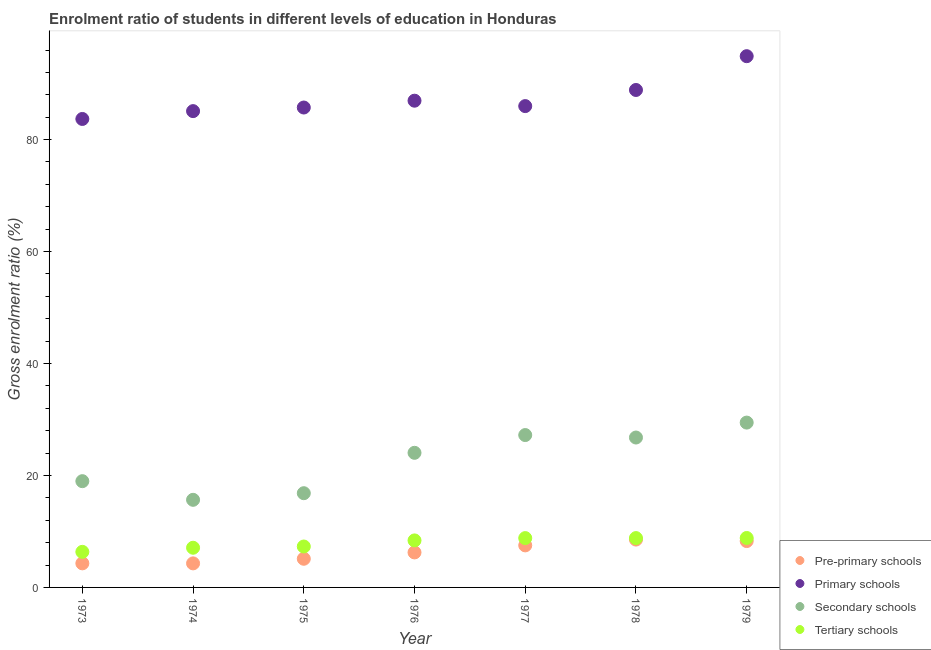What is the gross enrolment ratio in primary schools in 1977?
Ensure brevity in your answer.  85.99. Across all years, what is the maximum gross enrolment ratio in tertiary schools?
Provide a succinct answer. 8.83. Across all years, what is the minimum gross enrolment ratio in primary schools?
Ensure brevity in your answer.  83.69. In which year was the gross enrolment ratio in secondary schools maximum?
Provide a succinct answer. 1979. What is the total gross enrolment ratio in primary schools in the graph?
Provide a succinct answer. 611.21. What is the difference between the gross enrolment ratio in primary schools in 1977 and that in 1979?
Make the answer very short. -8.92. What is the difference between the gross enrolment ratio in pre-primary schools in 1974 and the gross enrolment ratio in tertiary schools in 1973?
Provide a succinct answer. -2.06. What is the average gross enrolment ratio in tertiary schools per year?
Provide a succinct answer. 7.94. In the year 1978, what is the difference between the gross enrolment ratio in secondary schools and gross enrolment ratio in pre-primary schools?
Provide a short and direct response. 18.23. In how many years, is the gross enrolment ratio in tertiary schools greater than 68 %?
Offer a very short reply. 0. What is the ratio of the gross enrolment ratio in tertiary schools in 1973 to that in 1977?
Your answer should be very brief. 0.72. Is the difference between the gross enrolment ratio in tertiary schools in 1974 and 1976 greater than the difference between the gross enrolment ratio in primary schools in 1974 and 1976?
Give a very brief answer. Yes. What is the difference between the highest and the second highest gross enrolment ratio in secondary schools?
Provide a short and direct response. 2.23. What is the difference between the highest and the lowest gross enrolment ratio in secondary schools?
Ensure brevity in your answer.  13.8. Is it the case that in every year, the sum of the gross enrolment ratio in primary schools and gross enrolment ratio in tertiary schools is greater than the sum of gross enrolment ratio in pre-primary schools and gross enrolment ratio in secondary schools?
Your response must be concise. No. Is the gross enrolment ratio in pre-primary schools strictly greater than the gross enrolment ratio in primary schools over the years?
Your answer should be compact. No. Is the gross enrolment ratio in pre-primary schools strictly less than the gross enrolment ratio in tertiary schools over the years?
Give a very brief answer. Yes. How many dotlines are there?
Offer a terse response. 4. How many years are there in the graph?
Make the answer very short. 7. What is the difference between two consecutive major ticks on the Y-axis?
Offer a very short reply. 20. Does the graph contain grids?
Your answer should be very brief. No. Where does the legend appear in the graph?
Keep it short and to the point. Bottom right. How are the legend labels stacked?
Offer a terse response. Vertical. What is the title of the graph?
Ensure brevity in your answer.  Enrolment ratio of students in different levels of education in Honduras. Does "Trade" appear as one of the legend labels in the graph?
Provide a succinct answer. No. What is the label or title of the X-axis?
Offer a very short reply. Year. What is the Gross enrolment ratio (%) of Pre-primary schools in 1973?
Your response must be concise. 4.3. What is the Gross enrolment ratio (%) in Primary schools in 1973?
Your response must be concise. 83.69. What is the Gross enrolment ratio (%) in Secondary schools in 1973?
Make the answer very short. 18.98. What is the Gross enrolment ratio (%) in Tertiary schools in 1973?
Make the answer very short. 6.35. What is the Gross enrolment ratio (%) in Pre-primary schools in 1974?
Provide a short and direct response. 4.3. What is the Gross enrolment ratio (%) of Primary schools in 1974?
Provide a short and direct response. 85.09. What is the Gross enrolment ratio (%) of Secondary schools in 1974?
Your response must be concise. 15.65. What is the Gross enrolment ratio (%) of Tertiary schools in 1974?
Make the answer very short. 7.09. What is the Gross enrolment ratio (%) of Pre-primary schools in 1975?
Your answer should be compact. 5.12. What is the Gross enrolment ratio (%) of Primary schools in 1975?
Provide a succinct answer. 85.73. What is the Gross enrolment ratio (%) of Secondary schools in 1975?
Offer a very short reply. 16.83. What is the Gross enrolment ratio (%) of Tertiary schools in 1975?
Make the answer very short. 7.31. What is the Gross enrolment ratio (%) of Pre-primary schools in 1976?
Your answer should be very brief. 6.25. What is the Gross enrolment ratio (%) of Primary schools in 1976?
Your response must be concise. 86.95. What is the Gross enrolment ratio (%) of Secondary schools in 1976?
Ensure brevity in your answer.  24.05. What is the Gross enrolment ratio (%) of Tertiary schools in 1976?
Make the answer very short. 8.4. What is the Gross enrolment ratio (%) of Pre-primary schools in 1977?
Ensure brevity in your answer.  7.51. What is the Gross enrolment ratio (%) of Primary schools in 1977?
Provide a succinct answer. 85.99. What is the Gross enrolment ratio (%) of Secondary schools in 1977?
Keep it short and to the point. 27.22. What is the Gross enrolment ratio (%) in Tertiary schools in 1977?
Offer a very short reply. 8.81. What is the Gross enrolment ratio (%) in Pre-primary schools in 1978?
Provide a succinct answer. 8.55. What is the Gross enrolment ratio (%) in Primary schools in 1978?
Make the answer very short. 88.86. What is the Gross enrolment ratio (%) of Secondary schools in 1978?
Your response must be concise. 26.78. What is the Gross enrolment ratio (%) in Tertiary schools in 1978?
Your response must be concise. 8.81. What is the Gross enrolment ratio (%) of Pre-primary schools in 1979?
Make the answer very short. 8.28. What is the Gross enrolment ratio (%) in Primary schools in 1979?
Offer a terse response. 94.9. What is the Gross enrolment ratio (%) in Secondary schools in 1979?
Your response must be concise. 29.45. What is the Gross enrolment ratio (%) in Tertiary schools in 1979?
Your response must be concise. 8.83. Across all years, what is the maximum Gross enrolment ratio (%) of Pre-primary schools?
Your answer should be compact. 8.55. Across all years, what is the maximum Gross enrolment ratio (%) in Primary schools?
Keep it short and to the point. 94.9. Across all years, what is the maximum Gross enrolment ratio (%) in Secondary schools?
Your response must be concise. 29.45. Across all years, what is the maximum Gross enrolment ratio (%) in Tertiary schools?
Keep it short and to the point. 8.83. Across all years, what is the minimum Gross enrolment ratio (%) in Pre-primary schools?
Your response must be concise. 4.3. Across all years, what is the minimum Gross enrolment ratio (%) in Primary schools?
Ensure brevity in your answer.  83.69. Across all years, what is the minimum Gross enrolment ratio (%) of Secondary schools?
Provide a succinct answer. 15.65. Across all years, what is the minimum Gross enrolment ratio (%) in Tertiary schools?
Provide a short and direct response. 6.35. What is the total Gross enrolment ratio (%) in Pre-primary schools in the graph?
Give a very brief answer. 44.31. What is the total Gross enrolment ratio (%) in Primary schools in the graph?
Give a very brief answer. 611.21. What is the total Gross enrolment ratio (%) of Secondary schools in the graph?
Provide a succinct answer. 158.95. What is the total Gross enrolment ratio (%) of Tertiary schools in the graph?
Your answer should be very brief. 55.61. What is the difference between the Gross enrolment ratio (%) of Pre-primary schools in 1973 and that in 1974?
Your answer should be very brief. 0. What is the difference between the Gross enrolment ratio (%) of Primary schools in 1973 and that in 1974?
Keep it short and to the point. -1.4. What is the difference between the Gross enrolment ratio (%) of Secondary schools in 1973 and that in 1974?
Provide a short and direct response. 3.33. What is the difference between the Gross enrolment ratio (%) in Tertiary schools in 1973 and that in 1974?
Keep it short and to the point. -0.73. What is the difference between the Gross enrolment ratio (%) in Pre-primary schools in 1973 and that in 1975?
Your answer should be very brief. -0.82. What is the difference between the Gross enrolment ratio (%) in Primary schools in 1973 and that in 1975?
Offer a terse response. -2.04. What is the difference between the Gross enrolment ratio (%) in Secondary schools in 1973 and that in 1975?
Make the answer very short. 2.15. What is the difference between the Gross enrolment ratio (%) of Tertiary schools in 1973 and that in 1975?
Keep it short and to the point. -0.96. What is the difference between the Gross enrolment ratio (%) in Pre-primary schools in 1973 and that in 1976?
Offer a very short reply. -1.95. What is the difference between the Gross enrolment ratio (%) in Primary schools in 1973 and that in 1976?
Your answer should be very brief. -3.26. What is the difference between the Gross enrolment ratio (%) in Secondary schools in 1973 and that in 1976?
Your answer should be compact. -5.06. What is the difference between the Gross enrolment ratio (%) of Tertiary schools in 1973 and that in 1976?
Provide a short and direct response. -2.04. What is the difference between the Gross enrolment ratio (%) in Pre-primary schools in 1973 and that in 1977?
Provide a short and direct response. -3.21. What is the difference between the Gross enrolment ratio (%) in Primary schools in 1973 and that in 1977?
Make the answer very short. -2.3. What is the difference between the Gross enrolment ratio (%) of Secondary schools in 1973 and that in 1977?
Offer a terse response. -8.24. What is the difference between the Gross enrolment ratio (%) of Tertiary schools in 1973 and that in 1977?
Make the answer very short. -2.46. What is the difference between the Gross enrolment ratio (%) of Pre-primary schools in 1973 and that in 1978?
Keep it short and to the point. -4.25. What is the difference between the Gross enrolment ratio (%) in Primary schools in 1973 and that in 1978?
Your answer should be compact. -5.18. What is the difference between the Gross enrolment ratio (%) in Secondary schools in 1973 and that in 1978?
Keep it short and to the point. -7.8. What is the difference between the Gross enrolment ratio (%) of Tertiary schools in 1973 and that in 1978?
Offer a very short reply. -2.46. What is the difference between the Gross enrolment ratio (%) of Pre-primary schools in 1973 and that in 1979?
Make the answer very short. -3.98. What is the difference between the Gross enrolment ratio (%) of Primary schools in 1973 and that in 1979?
Offer a terse response. -11.21. What is the difference between the Gross enrolment ratio (%) in Secondary schools in 1973 and that in 1979?
Give a very brief answer. -10.46. What is the difference between the Gross enrolment ratio (%) of Tertiary schools in 1973 and that in 1979?
Offer a very short reply. -2.48. What is the difference between the Gross enrolment ratio (%) in Pre-primary schools in 1974 and that in 1975?
Offer a terse response. -0.82. What is the difference between the Gross enrolment ratio (%) of Primary schools in 1974 and that in 1975?
Make the answer very short. -0.64. What is the difference between the Gross enrolment ratio (%) of Secondary schools in 1974 and that in 1975?
Your answer should be very brief. -1.18. What is the difference between the Gross enrolment ratio (%) in Tertiary schools in 1974 and that in 1975?
Ensure brevity in your answer.  -0.22. What is the difference between the Gross enrolment ratio (%) in Pre-primary schools in 1974 and that in 1976?
Offer a very short reply. -1.96. What is the difference between the Gross enrolment ratio (%) of Primary schools in 1974 and that in 1976?
Provide a short and direct response. -1.86. What is the difference between the Gross enrolment ratio (%) of Secondary schools in 1974 and that in 1976?
Your response must be concise. -8.4. What is the difference between the Gross enrolment ratio (%) in Tertiary schools in 1974 and that in 1976?
Your answer should be compact. -1.31. What is the difference between the Gross enrolment ratio (%) in Pre-primary schools in 1974 and that in 1977?
Make the answer very short. -3.21. What is the difference between the Gross enrolment ratio (%) in Primary schools in 1974 and that in 1977?
Keep it short and to the point. -0.9. What is the difference between the Gross enrolment ratio (%) of Secondary schools in 1974 and that in 1977?
Your answer should be compact. -11.57. What is the difference between the Gross enrolment ratio (%) in Tertiary schools in 1974 and that in 1977?
Your answer should be very brief. -1.72. What is the difference between the Gross enrolment ratio (%) in Pre-primary schools in 1974 and that in 1978?
Your answer should be compact. -4.25. What is the difference between the Gross enrolment ratio (%) of Primary schools in 1974 and that in 1978?
Your response must be concise. -3.78. What is the difference between the Gross enrolment ratio (%) of Secondary schools in 1974 and that in 1978?
Your response must be concise. -11.13. What is the difference between the Gross enrolment ratio (%) in Tertiary schools in 1974 and that in 1978?
Give a very brief answer. -1.73. What is the difference between the Gross enrolment ratio (%) of Pre-primary schools in 1974 and that in 1979?
Make the answer very short. -3.98. What is the difference between the Gross enrolment ratio (%) of Primary schools in 1974 and that in 1979?
Offer a terse response. -9.81. What is the difference between the Gross enrolment ratio (%) in Secondary schools in 1974 and that in 1979?
Offer a very short reply. -13.8. What is the difference between the Gross enrolment ratio (%) of Tertiary schools in 1974 and that in 1979?
Your response must be concise. -1.74. What is the difference between the Gross enrolment ratio (%) of Pre-primary schools in 1975 and that in 1976?
Your answer should be compact. -1.13. What is the difference between the Gross enrolment ratio (%) in Primary schools in 1975 and that in 1976?
Provide a succinct answer. -1.22. What is the difference between the Gross enrolment ratio (%) in Secondary schools in 1975 and that in 1976?
Your answer should be compact. -7.21. What is the difference between the Gross enrolment ratio (%) of Tertiary schools in 1975 and that in 1976?
Your answer should be very brief. -1.09. What is the difference between the Gross enrolment ratio (%) of Pre-primary schools in 1975 and that in 1977?
Your answer should be very brief. -2.39. What is the difference between the Gross enrolment ratio (%) of Primary schools in 1975 and that in 1977?
Your response must be concise. -0.26. What is the difference between the Gross enrolment ratio (%) in Secondary schools in 1975 and that in 1977?
Make the answer very short. -10.39. What is the difference between the Gross enrolment ratio (%) of Tertiary schools in 1975 and that in 1977?
Your response must be concise. -1.5. What is the difference between the Gross enrolment ratio (%) of Pre-primary schools in 1975 and that in 1978?
Your answer should be very brief. -3.43. What is the difference between the Gross enrolment ratio (%) of Primary schools in 1975 and that in 1978?
Make the answer very short. -3.13. What is the difference between the Gross enrolment ratio (%) in Secondary schools in 1975 and that in 1978?
Ensure brevity in your answer.  -9.95. What is the difference between the Gross enrolment ratio (%) in Tertiary schools in 1975 and that in 1978?
Ensure brevity in your answer.  -1.5. What is the difference between the Gross enrolment ratio (%) of Pre-primary schools in 1975 and that in 1979?
Your answer should be very brief. -3.16. What is the difference between the Gross enrolment ratio (%) in Primary schools in 1975 and that in 1979?
Offer a very short reply. -9.17. What is the difference between the Gross enrolment ratio (%) in Secondary schools in 1975 and that in 1979?
Make the answer very short. -12.61. What is the difference between the Gross enrolment ratio (%) of Tertiary schools in 1975 and that in 1979?
Provide a succinct answer. -1.52. What is the difference between the Gross enrolment ratio (%) in Pre-primary schools in 1976 and that in 1977?
Give a very brief answer. -1.26. What is the difference between the Gross enrolment ratio (%) of Primary schools in 1976 and that in 1977?
Offer a very short reply. 0.97. What is the difference between the Gross enrolment ratio (%) of Secondary schools in 1976 and that in 1977?
Offer a terse response. -3.17. What is the difference between the Gross enrolment ratio (%) in Tertiary schools in 1976 and that in 1977?
Your response must be concise. -0.41. What is the difference between the Gross enrolment ratio (%) of Pre-primary schools in 1976 and that in 1978?
Your answer should be compact. -2.3. What is the difference between the Gross enrolment ratio (%) in Primary schools in 1976 and that in 1978?
Ensure brevity in your answer.  -1.91. What is the difference between the Gross enrolment ratio (%) of Secondary schools in 1976 and that in 1978?
Offer a terse response. -2.73. What is the difference between the Gross enrolment ratio (%) in Tertiary schools in 1976 and that in 1978?
Offer a terse response. -0.42. What is the difference between the Gross enrolment ratio (%) in Pre-primary schools in 1976 and that in 1979?
Provide a succinct answer. -2.03. What is the difference between the Gross enrolment ratio (%) of Primary schools in 1976 and that in 1979?
Provide a short and direct response. -7.95. What is the difference between the Gross enrolment ratio (%) in Secondary schools in 1976 and that in 1979?
Provide a succinct answer. -5.4. What is the difference between the Gross enrolment ratio (%) in Tertiary schools in 1976 and that in 1979?
Your response must be concise. -0.43. What is the difference between the Gross enrolment ratio (%) in Pre-primary schools in 1977 and that in 1978?
Ensure brevity in your answer.  -1.04. What is the difference between the Gross enrolment ratio (%) in Primary schools in 1977 and that in 1978?
Offer a very short reply. -2.88. What is the difference between the Gross enrolment ratio (%) in Secondary schools in 1977 and that in 1978?
Give a very brief answer. 0.44. What is the difference between the Gross enrolment ratio (%) in Tertiary schools in 1977 and that in 1978?
Offer a terse response. -0. What is the difference between the Gross enrolment ratio (%) of Pre-primary schools in 1977 and that in 1979?
Ensure brevity in your answer.  -0.77. What is the difference between the Gross enrolment ratio (%) in Primary schools in 1977 and that in 1979?
Give a very brief answer. -8.92. What is the difference between the Gross enrolment ratio (%) of Secondary schools in 1977 and that in 1979?
Give a very brief answer. -2.23. What is the difference between the Gross enrolment ratio (%) in Tertiary schools in 1977 and that in 1979?
Give a very brief answer. -0.02. What is the difference between the Gross enrolment ratio (%) in Pre-primary schools in 1978 and that in 1979?
Offer a terse response. 0.27. What is the difference between the Gross enrolment ratio (%) in Primary schools in 1978 and that in 1979?
Your answer should be very brief. -6.04. What is the difference between the Gross enrolment ratio (%) in Secondary schools in 1978 and that in 1979?
Give a very brief answer. -2.67. What is the difference between the Gross enrolment ratio (%) in Tertiary schools in 1978 and that in 1979?
Your answer should be compact. -0.02. What is the difference between the Gross enrolment ratio (%) of Pre-primary schools in 1973 and the Gross enrolment ratio (%) of Primary schools in 1974?
Your answer should be very brief. -80.79. What is the difference between the Gross enrolment ratio (%) in Pre-primary schools in 1973 and the Gross enrolment ratio (%) in Secondary schools in 1974?
Provide a short and direct response. -11.35. What is the difference between the Gross enrolment ratio (%) of Pre-primary schools in 1973 and the Gross enrolment ratio (%) of Tertiary schools in 1974?
Offer a terse response. -2.79. What is the difference between the Gross enrolment ratio (%) in Primary schools in 1973 and the Gross enrolment ratio (%) in Secondary schools in 1974?
Your answer should be compact. 68.04. What is the difference between the Gross enrolment ratio (%) of Primary schools in 1973 and the Gross enrolment ratio (%) of Tertiary schools in 1974?
Your answer should be compact. 76.6. What is the difference between the Gross enrolment ratio (%) in Secondary schools in 1973 and the Gross enrolment ratio (%) in Tertiary schools in 1974?
Make the answer very short. 11.89. What is the difference between the Gross enrolment ratio (%) of Pre-primary schools in 1973 and the Gross enrolment ratio (%) of Primary schools in 1975?
Provide a short and direct response. -81.43. What is the difference between the Gross enrolment ratio (%) in Pre-primary schools in 1973 and the Gross enrolment ratio (%) in Secondary schools in 1975?
Keep it short and to the point. -12.53. What is the difference between the Gross enrolment ratio (%) in Pre-primary schools in 1973 and the Gross enrolment ratio (%) in Tertiary schools in 1975?
Give a very brief answer. -3.01. What is the difference between the Gross enrolment ratio (%) in Primary schools in 1973 and the Gross enrolment ratio (%) in Secondary schools in 1975?
Give a very brief answer. 66.85. What is the difference between the Gross enrolment ratio (%) of Primary schools in 1973 and the Gross enrolment ratio (%) of Tertiary schools in 1975?
Offer a terse response. 76.38. What is the difference between the Gross enrolment ratio (%) of Secondary schools in 1973 and the Gross enrolment ratio (%) of Tertiary schools in 1975?
Ensure brevity in your answer.  11.67. What is the difference between the Gross enrolment ratio (%) in Pre-primary schools in 1973 and the Gross enrolment ratio (%) in Primary schools in 1976?
Ensure brevity in your answer.  -82.65. What is the difference between the Gross enrolment ratio (%) of Pre-primary schools in 1973 and the Gross enrolment ratio (%) of Secondary schools in 1976?
Provide a short and direct response. -19.75. What is the difference between the Gross enrolment ratio (%) in Pre-primary schools in 1973 and the Gross enrolment ratio (%) in Tertiary schools in 1976?
Provide a succinct answer. -4.1. What is the difference between the Gross enrolment ratio (%) of Primary schools in 1973 and the Gross enrolment ratio (%) of Secondary schools in 1976?
Provide a short and direct response. 59.64. What is the difference between the Gross enrolment ratio (%) of Primary schools in 1973 and the Gross enrolment ratio (%) of Tertiary schools in 1976?
Keep it short and to the point. 75.29. What is the difference between the Gross enrolment ratio (%) of Secondary schools in 1973 and the Gross enrolment ratio (%) of Tertiary schools in 1976?
Offer a terse response. 10.58. What is the difference between the Gross enrolment ratio (%) in Pre-primary schools in 1973 and the Gross enrolment ratio (%) in Primary schools in 1977?
Ensure brevity in your answer.  -81.68. What is the difference between the Gross enrolment ratio (%) in Pre-primary schools in 1973 and the Gross enrolment ratio (%) in Secondary schools in 1977?
Your response must be concise. -22.92. What is the difference between the Gross enrolment ratio (%) of Pre-primary schools in 1973 and the Gross enrolment ratio (%) of Tertiary schools in 1977?
Make the answer very short. -4.51. What is the difference between the Gross enrolment ratio (%) in Primary schools in 1973 and the Gross enrolment ratio (%) in Secondary schools in 1977?
Provide a succinct answer. 56.47. What is the difference between the Gross enrolment ratio (%) of Primary schools in 1973 and the Gross enrolment ratio (%) of Tertiary schools in 1977?
Your answer should be very brief. 74.87. What is the difference between the Gross enrolment ratio (%) of Secondary schools in 1973 and the Gross enrolment ratio (%) of Tertiary schools in 1977?
Ensure brevity in your answer.  10.17. What is the difference between the Gross enrolment ratio (%) of Pre-primary schools in 1973 and the Gross enrolment ratio (%) of Primary schools in 1978?
Your answer should be very brief. -84.56. What is the difference between the Gross enrolment ratio (%) in Pre-primary schools in 1973 and the Gross enrolment ratio (%) in Secondary schools in 1978?
Give a very brief answer. -22.48. What is the difference between the Gross enrolment ratio (%) in Pre-primary schools in 1973 and the Gross enrolment ratio (%) in Tertiary schools in 1978?
Your answer should be compact. -4.51. What is the difference between the Gross enrolment ratio (%) in Primary schools in 1973 and the Gross enrolment ratio (%) in Secondary schools in 1978?
Offer a very short reply. 56.91. What is the difference between the Gross enrolment ratio (%) in Primary schools in 1973 and the Gross enrolment ratio (%) in Tertiary schools in 1978?
Your answer should be very brief. 74.87. What is the difference between the Gross enrolment ratio (%) of Secondary schools in 1973 and the Gross enrolment ratio (%) of Tertiary schools in 1978?
Your answer should be compact. 10.17. What is the difference between the Gross enrolment ratio (%) in Pre-primary schools in 1973 and the Gross enrolment ratio (%) in Primary schools in 1979?
Ensure brevity in your answer.  -90.6. What is the difference between the Gross enrolment ratio (%) in Pre-primary schools in 1973 and the Gross enrolment ratio (%) in Secondary schools in 1979?
Give a very brief answer. -25.15. What is the difference between the Gross enrolment ratio (%) in Pre-primary schools in 1973 and the Gross enrolment ratio (%) in Tertiary schools in 1979?
Your response must be concise. -4.53. What is the difference between the Gross enrolment ratio (%) of Primary schools in 1973 and the Gross enrolment ratio (%) of Secondary schools in 1979?
Keep it short and to the point. 54.24. What is the difference between the Gross enrolment ratio (%) in Primary schools in 1973 and the Gross enrolment ratio (%) in Tertiary schools in 1979?
Your answer should be very brief. 74.86. What is the difference between the Gross enrolment ratio (%) in Secondary schools in 1973 and the Gross enrolment ratio (%) in Tertiary schools in 1979?
Keep it short and to the point. 10.15. What is the difference between the Gross enrolment ratio (%) in Pre-primary schools in 1974 and the Gross enrolment ratio (%) in Primary schools in 1975?
Provide a short and direct response. -81.43. What is the difference between the Gross enrolment ratio (%) in Pre-primary schools in 1974 and the Gross enrolment ratio (%) in Secondary schools in 1975?
Ensure brevity in your answer.  -12.54. What is the difference between the Gross enrolment ratio (%) in Pre-primary schools in 1974 and the Gross enrolment ratio (%) in Tertiary schools in 1975?
Your answer should be very brief. -3.01. What is the difference between the Gross enrolment ratio (%) in Primary schools in 1974 and the Gross enrolment ratio (%) in Secondary schools in 1975?
Provide a short and direct response. 68.25. What is the difference between the Gross enrolment ratio (%) of Primary schools in 1974 and the Gross enrolment ratio (%) of Tertiary schools in 1975?
Keep it short and to the point. 77.78. What is the difference between the Gross enrolment ratio (%) in Secondary schools in 1974 and the Gross enrolment ratio (%) in Tertiary schools in 1975?
Your response must be concise. 8.34. What is the difference between the Gross enrolment ratio (%) in Pre-primary schools in 1974 and the Gross enrolment ratio (%) in Primary schools in 1976?
Make the answer very short. -82.65. What is the difference between the Gross enrolment ratio (%) in Pre-primary schools in 1974 and the Gross enrolment ratio (%) in Secondary schools in 1976?
Provide a short and direct response. -19.75. What is the difference between the Gross enrolment ratio (%) of Pre-primary schools in 1974 and the Gross enrolment ratio (%) of Tertiary schools in 1976?
Your answer should be very brief. -4.1. What is the difference between the Gross enrolment ratio (%) of Primary schools in 1974 and the Gross enrolment ratio (%) of Secondary schools in 1976?
Offer a very short reply. 61.04. What is the difference between the Gross enrolment ratio (%) of Primary schools in 1974 and the Gross enrolment ratio (%) of Tertiary schools in 1976?
Offer a very short reply. 76.69. What is the difference between the Gross enrolment ratio (%) in Secondary schools in 1974 and the Gross enrolment ratio (%) in Tertiary schools in 1976?
Keep it short and to the point. 7.25. What is the difference between the Gross enrolment ratio (%) in Pre-primary schools in 1974 and the Gross enrolment ratio (%) in Primary schools in 1977?
Provide a short and direct response. -81.69. What is the difference between the Gross enrolment ratio (%) in Pre-primary schools in 1974 and the Gross enrolment ratio (%) in Secondary schools in 1977?
Offer a very short reply. -22.92. What is the difference between the Gross enrolment ratio (%) in Pre-primary schools in 1974 and the Gross enrolment ratio (%) in Tertiary schools in 1977?
Your response must be concise. -4.52. What is the difference between the Gross enrolment ratio (%) in Primary schools in 1974 and the Gross enrolment ratio (%) in Secondary schools in 1977?
Your response must be concise. 57.87. What is the difference between the Gross enrolment ratio (%) of Primary schools in 1974 and the Gross enrolment ratio (%) of Tertiary schools in 1977?
Your response must be concise. 76.27. What is the difference between the Gross enrolment ratio (%) of Secondary schools in 1974 and the Gross enrolment ratio (%) of Tertiary schools in 1977?
Offer a terse response. 6.84. What is the difference between the Gross enrolment ratio (%) in Pre-primary schools in 1974 and the Gross enrolment ratio (%) in Primary schools in 1978?
Ensure brevity in your answer.  -84.57. What is the difference between the Gross enrolment ratio (%) in Pre-primary schools in 1974 and the Gross enrolment ratio (%) in Secondary schools in 1978?
Make the answer very short. -22.48. What is the difference between the Gross enrolment ratio (%) of Pre-primary schools in 1974 and the Gross enrolment ratio (%) of Tertiary schools in 1978?
Keep it short and to the point. -4.52. What is the difference between the Gross enrolment ratio (%) of Primary schools in 1974 and the Gross enrolment ratio (%) of Secondary schools in 1978?
Provide a succinct answer. 58.31. What is the difference between the Gross enrolment ratio (%) in Primary schools in 1974 and the Gross enrolment ratio (%) in Tertiary schools in 1978?
Offer a very short reply. 76.27. What is the difference between the Gross enrolment ratio (%) of Secondary schools in 1974 and the Gross enrolment ratio (%) of Tertiary schools in 1978?
Provide a succinct answer. 6.84. What is the difference between the Gross enrolment ratio (%) of Pre-primary schools in 1974 and the Gross enrolment ratio (%) of Primary schools in 1979?
Ensure brevity in your answer.  -90.61. What is the difference between the Gross enrolment ratio (%) of Pre-primary schools in 1974 and the Gross enrolment ratio (%) of Secondary schools in 1979?
Offer a very short reply. -25.15. What is the difference between the Gross enrolment ratio (%) of Pre-primary schools in 1974 and the Gross enrolment ratio (%) of Tertiary schools in 1979?
Offer a very short reply. -4.54. What is the difference between the Gross enrolment ratio (%) of Primary schools in 1974 and the Gross enrolment ratio (%) of Secondary schools in 1979?
Your answer should be very brief. 55.64. What is the difference between the Gross enrolment ratio (%) of Primary schools in 1974 and the Gross enrolment ratio (%) of Tertiary schools in 1979?
Provide a short and direct response. 76.26. What is the difference between the Gross enrolment ratio (%) of Secondary schools in 1974 and the Gross enrolment ratio (%) of Tertiary schools in 1979?
Offer a very short reply. 6.82. What is the difference between the Gross enrolment ratio (%) of Pre-primary schools in 1975 and the Gross enrolment ratio (%) of Primary schools in 1976?
Offer a terse response. -81.83. What is the difference between the Gross enrolment ratio (%) of Pre-primary schools in 1975 and the Gross enrolment ratio (%) of Secondary schools in 1976?
Your answer should be compact. -18.93. What is the difference between the Gross enrolment ratio (%) in Pre-primary schools in 1975 and the Gross enrolment ratio (%) in Tertiary schools in 1976?
Make the answer very short. -3.28. What is the difference between the Gross enrolment ratio (%) in Primary schools in 1975 and the Gross enrolment ratio (%) in Secondary schools in 1976?
Ensure brevity in your answer.  61.68. What is the difference between the Gross enrolment ratio (%) of Primary schools in 1975 and the Gross enrolment ratio (%) of Tertiary schools in 1976?
Your answer should be compact. 77.33. What is the difference between the Gross enrolment ratio (%) of Secondary schools in 1975 and the Gross enrolment ratio (%) of Tertiary schools in 1976?
Your answer should be very brief. 8.43. What is the difference between the Gross enrolment ratio (%) in Pre-primary schools in 1975 and the Gross enrolment ratio (%) in Primary schools in 1977?
Make the answer very short. -80.87. What is the difference between the Gross enrolment ratio (%) of Pre-primary schools in 1975 and the Gross enrolment ratio (%) of Secondary schools in 1977?
Give a very brief answer. -22.1. What is the difference between the Gross enrolment ratio (%) of Pre-primary schools in 1975 and the Gross enrolment ratio (%) of Tertiary schools in 1977?
Keep it short and to the point. -3.69. What is the difference between the Gross enrolment ratio (%) in Primary schools in 1975 and the Gross enrolment ratio (%) in Secondary schools in 1977?
Give a very brief answer. 58.51. What is the difference between the Gross enrolment ratio (%) in Primary schools in 1975 and the Gross enrolment ratio (%) in Tertiary schools in 1977?
Make the answer very short. 76.92. What is the difference between the Gross enrolment ratio (%) of Secondary schools in 1975 and the Gross enrolment ratio (%) of Tertiary schools in 1977?
Provide a short and direct response. 8.02. What is the difference between the Gross enrolment ratio (%) in Pre-primary schools in 1975 and the Gross enrolment ratio (%) in Primary schools in 1978?
Keep it short and to the point. -83.75. What is the difference between the Gross enrolment ratio (%) of Pre-primary schools in 1975 and the Gross enrolment ratio (%) of Secondary schools in 1978?
Make the answer very short. -21.66. What is the difference between the Gross enrolment ratio (%) of Pre-primary schools in 1975 and the Gross enrolment ratio (%) of Tertiary schools in 1978?
Your answer should be compact. -3.69. What is the difference between the Gross enrolment ratio (%) in Primary schools in 1975 and the Gross enrolment ratio (%) in Secondary schools in 1978?
Your answer should be very brief. 58.95. What is the difference between the Gross enrolment ratio (%) of Primary schools in 1975 and the Gross enrolment ratio (%) of Tertiary schools in 1978?
Your answer should be compact. 76.92. What is the difference between the Gross enrolment ratio (%) of Secondary schools in 1975 and the Gross enrolment ratio (%) of Tertiary schools in 1978?
Your response must be concise. 8.02. What is the difference between the Gross enrolment ratio (%) of Pre-primary schools in 1975 and the Gross enrolment ratio (%) of Primary schools in 1979?
Provide a succinct answer. -89.78. What is the difference between the Gross enrolment ratio (%) in Pre-primary schools in 1975 and the Gross enrolment ratio (%) in Secondary schools in 1979?
Make the answer very short. -24.33. What is the difference between the Gross enrolment ratio (%) in Pre-primary schools in 1975 and the Gross enrolment ratio (%) in Tertiary schools in 1979?
Keep it short and to the point. -3.71. What is the difference between the Gross enrolment ratio (%) of Primary schools in 1975 and the Gross enrolment ratio (%) of Secondary schools in 1979?
Give a very brief answer. 56.28. What is the difference between the Gross enrolment ratio (%) in Primary schools in 1975 and the Gross enrolment ratio (%) in Tertiary schools in 1979?
Provide a succinct answer. 76.9. What is the difference between the Gross enrolment ratio (%) of Secondary schools in 1975 and the Gross enrolment ratio (%) of Tertiary schools in 1979?
Ensure brevity in your answer.  8. What is the difference between the Gross enrolment ratio (%) in Pre-primary schools in 1976 and the Gross enrolment ratio (%) in Primary schools in 1977?
Make the answer very short. -79.73. What is the difference between the Gross enrolment ratio (%) in Pre-primary schools in 1976 and the Gross enrolment ratio (%) in Secondary schools in 1977?
Offer a very short reply. -20.97. What is the difference between the Gross enrolment ratio (%) in Pre-primary schools in 1976 and the Gross enrolment ratio (%) in Tertiary schools in 1977?
Provide a short and direct response. -2.56. What is the difference between the Gross enrolment ratio (%) in Primary schools in 1976 and the Gross enrolment ratio (%) in Secondary schools in 1977?
Provide a succinct answer. 59.73. What is the difference between the Gross enrolment ratio (%) of Primary schools in 1976 and the Gross enrolment ratio (%) of Tertiary schools in 1977?
Keep it short and to the point. 78.14. What is the difference between the Gross enrolment ratio (%) of Secondary schools in 1976 and the Gross enrolment ratio (%) of Tertiary schools in 1977?
Offer a very short reply. 15.23. What is the difference between the Gross enrolment ratio (%) in Pre-primary schools in 1976 and the Gross enrolment ratio (%) in Primary schools in 1978?
Make the answer very short. -82.61. What is the difference between the Gross enrolment ratio (%) of Pre-primary schools in 1976 and the Gross enrolment ratio (%) of Secondary schools in 1978?
Ensure brevity in your answer.  -20.53. What is the difference between the Gross enrolment ratio (%) of Pre-primary schools in 1976 and the Gross enrolment ratio (%) of Tertiary schools in 1978?
Your answer should be compact. -2.56. What is the difference between the Gross enrolment ratio (%) in Primary schools in 1976 and the Gross enrolment ratio (%) in Secondary schools in 1978?
Your answer should be very brief. 60.17. What is the difference between the Gross enrolment ratio (%) of Primary schools in 1976 and the Gross enrolment ratio (%) of Tertiary schools in 1978?
Your response must be concise. 78.14. What is the difference between the Gross enrolment ratio (%) in Secondary schools in 1976 and the Gross enrolment ratio (%) in Tertiary schools in 1978?
Offer a very short reply. 15.23. What is the difference between the Gross enrolment ratio (%) in Pre-primary schools in 1976 and the Gross enrolment ratio (%) in Primary schools in 1979?
Your response must be concise. -88.65. What is the difference between the Gross enrolment ratio (%) in Pre-primary schools in 1976 and the Gross enrolment ratio (%) in Secondary schools in 1979?
Keep it short and to the point. -23.19. What is the difference between the Gross enrolment ratio (%) in Pre-primary schools in 1976 and the Gross enrolment ratio (%) in Tertiary schools in 1979?
Ensure brevity in your answer.  -2.58. What is the difference between the Gross enrolment ratio (%) of Primary schools in 1976 and the Gross enrolment ratio (%) of Secondary schools in 1979?
Offer a terse response. 57.5. What is the difference between the Gross enrolment ratio (%) in Primary schools in 1976 and the Gross enrolment ratio (%) in Tertiary schools in 1979?
Offer a terse response. 78.12. What is the difference between the Gross enrolment ratio (%) of Secondary schools in 1976 and the Gross enrolment ratio (%) of Tertiary schools in 1979?
Provide a succinct answer. 15.21. What is the difference between the Gross enrolment ratio (%) of Pre-primary schools in 1977 and the Gross enrolment ratio (%) of Primary schools in 1978?
Provide a short and direct response. -81.36. What is the difference between the Gross enrolment ratio (%) of Pre-primary schools in 1977 and the Gross enrolment ratio (%) of Secondary schools in 1978?
Provide a short and direct response. -19.27. What is the difference between the Gross enrolment ratio (%) in Pre-primary schools in 1977 and the Gross enrolment ratio (%) in Tertiary schools in 1978?
Your response must be concise. -1.3. What is the difference between the Gross enrolment ratio (%) in Primary schools in 1977 and the Gross enrolment ratio (%) in Secondary schools in 1978?
Your answer should be compact. 59.21. What is the difference between the Gross enrolment ratio (%) of Primary schools in 1977 and the Gross enrolment ratio (%) of Tertiary schools in 1978?
Provide a succinct answer. 77.17. What is the difference between the Gross enrolment ratio (%) of Secondary schools in 1977 and the Gross enrolment ratio (%) of Tertiary schools in 1978?
Offer a terse response. 18.4. What is the difference between the Gross enrolment ratio (%) in Pre-primary schools in 1977 and the Gross enrolment ratio (%) in Primary schools in 1979?
Provide a succinct answer. -87.39. What is the difference between the Gross enrolment ratio (%) of Pre-primary schools in 1977 and the Gross enrolment ratio (%) of Secondary schools in 1979?
Your answer should be compact. -21.94. What is the difference between the Gross enrolment ratio (%) of Pre-primary schools in 1977 and the Gross enrolment ratio (%) of Tertiary schools in 1979?
Your answer should be compact. -1.32. What is the difference between the Gross enrolment ratio (%) in Primary schools in 1977 and the Gross enrolment ratio (%) in Secondary schools in 1979?
Your response must be concise. 56.54. What is the difference between the Gross enrolment ratio (%) of Primary schools in 1977 and the Gross enrolment ratio (%) of Tertiary schools in 1979?
Your answer should be compact. 77.15. What is the difference between the Gross enrolment ratio (%) in Secondary schools in 1977 and the Gross enrolment ratio (%) in Tertiary schools in 1979?
Make the answer very short. 18.39. What is the difference between the Gross enrolment ratio (%) of Pre-primary schools in 1978 and the Gross enrolment ratio (%) of Primary schools in 1979?
Give a very brief answer. -86.35. What is the difference between the Gross enrolment ratio (%) of Pre-primary schools in 1978 and the Gross enrolment ratio (%) of Secondary schools in 1979?
Make the answer very short. -20.9. What is the difference between the Gross enrolment ratio (%) in Pre-primary schools in 1978 and the Gross enrolment ratio (%) in Tertiary schools in 1979?
Offer a terse response. -0.28. What is the difference between the Gross enrolment ratio (%) in Primary schools in 1978 and the Gross enrolment ratio (%) in Secondary schools in 1979?
Provide a succinct answer. 59.42. What is the difference between the Gross enrolment ratio (%) of Primary schools in 1978 and the Gross enrolment ratio (%) of Tertiary schools in 1979?
Your answer should be compact. 80.03. What is the difference between the Gross enrolment ratio (%) in Secondary schools in 1978 and the Gross enrolment ratio (%) in Tertiary schools in 1979?
Your answer should be compact. 17.95. What is the average Gross enrolment ratio (%) in Pre-primary schools per year?
Your response must be concise. 6.33. What is the average Gross enrolment ratio (%) in Primary schools per year?
Keep it short and to the point. 87.32. What is the average Gross enrolment ratio (%) in Secondary schools per year?
Your answer should be very brief. 22.71. What is the average Gross enrolment ratio (%) of Tertiary schools per year?
Provide a succinct answer. 7.94. In the year 1973, what is the difference between the Gross enrolment ratio (%) in Pre-primary schools and Gross enrolment ratio (%) in Primary schools?
Your answer should be very brief. -79.39. In the year 1973, what is the difference between the Gross enrolment ratio (%) of Pre-primary schools and Gross enrolment ratio (%) of Secondary schools?
Make the answer very short. -14.68. In the year 1973, what is the difference between the Gross enrolment ratio (%) of Pre-primary schools and Gross enrolment ratio (%) of Tertiary schools?
Offer a terse response. -2.05. In the year 1973, what is the difference between the Gross enrolment ratio (%) in Primary schools and Gross enrolment ratio (%) in Secondary schools?
Your answer should be compact. 64.71. In the year 1973, what is the difference between the Gross enrolment ratio (%) of Primary schools and Gross enrolment ratio (%) of Tertiary schools?
Your response must be concise. 77.33. In the year 1973, what is the difference between the Gross enrolment ratio (%) of Secondary schools and Gross enrolment ratio (%) of Tertiary schools?
Your answer should be very brief. 12.63. In the year 1974, what is the difference between the Gross enrolment ratio (%) of Pre-primary schools and Gross enrolment ratio (%) of Primary schools?
Keep it short and to the point. -80.79. In the year 1974, what is the difference between the Gross enrolment ratio (%) in Pre-primary schools and Gross enrolment ratio (%) in Secondary schools?
Your answer should be compact. -11.35. In the year 1974, what is the difference between the Gross enrolment ratio (%) in Pre-primary schools and Gross enrolment ratio (%) in Tertiary schools?
Offer a terse response. -2.79. In the year 1974, what is the difference between the Gross enrolment ratio (%) in Primary schools and Gross enrolment ratio (%) in Secondary schools?
Make the answer very short. 69.44. In the year 1974, what is the difference between the Gross enrolment ratio (%) in Primary schools and Gross enrolment ratio (%) in Tertiary schools?
Your answer should be very brief. 78. In the year 1974, what is the difference between the Gross enrolment ratio (%) in Secondary schools and Gross enrolment ratio (%) in Tertiary schools?
Give a very brief answer. 8.56. In the year 1975, what is the difference between the Gross enrolment ratio (%) in Pre-primary schools and Gross enrolment ratio (%) in Primary schools?
Provide a succinct answer. -80.61. In the year 1975, what is the difference between the Gross enrolment ratio (%) in Pre-primary schools and Gross enrolment ratio (%) in Secondary schools?
Offer a terse response. -11.71. In the year 1975, what is the difference between the Gross enrolment ratio (%) of Pre-primary schools and Gross enrolment ratio (%) of Tertiary schools?
Keep it short and to the point. -2.19. In the year 1975, what is the difference between the Gross enrolment ratio (%) in Primary schools and Gross enrolment ratio (%) in Secondary schools?
Ensure brevity in your answer.  68.9. In the year 1975, what is the difference between the Gross enrolment ratio (%) of Primary schools and Gross enrolment ratio (%) of Tertiary schools?
Offer a very short reply. 78.42. In the year 1975, what is the difference between the Gross enrolment ratio (%) of Secondary schools and Gross enrolment ratio (%) of Tertiary schools?
Your answer should be very brief. 9.52. In the year 1976, what is the difference between the Gross enrolment ratio (%) in Pre-primary schools and Gross enrolment ratio (%) in Primary schools?
Offer a terse response. -80.7. In the year 1976, what is the difference between the Gross enrolment ratio (%) in Pre-primary schools and Gross enrolment ratio (%) in Secondary schools?
Your answer should be compact. -17.8. In the year 1976, what is the difference between the Gross enrolment ratio (%) in Pre-primary schools and Gross enrolment ratio (%) in Tertiary schools?
Provide a short and direct response. -2.15. In the year 1976, what is the difference between the Gross enrolment ratio (%) in Primary schools and Gross enrolment ratio (%) in Secondary schools?
Keep it short and to the point. 62.9. In the year 1976, what is the difference between the Gross enrolment ratio (%) in Primary schools and Gross enrolment ratio (%) in Tertiary schools?
Ensure brevity in your answer.  78.55. In the year 1976, what is the difference between the Gross enrolment ratio (%) in Secondary schools and Gross enrolment ratio (%) in Tertiary schools?
Your answer should be compact. 15.65. In the year 1977, what is the difference between the Gross enrolment ratio (%) of Pre-primary schools and Gross enrolment ratio (%) of Primary schools?
Offer a terse response. -78.48. In the year 1977, what is the difference between the Gross enrolment ratio (%) in Pre-primary schools and Gross enrolment ratio (%) in Secondary schools?
Your answer should be very brief. -19.71. In the year 1977, what is the difference between the Gross enrolment ratio (%) in Pre-primary schools and Gross enrolment ratio (%) in Tertiary schools?
Your answer should be very brief. -1.3. In the year 1977, what is the difference between the Gross enrolment ratio (%) of Primary schools and Gross enrolment ratio (%) of Secondary schools?
Ensure brevity in your answer.  58.77. In the year 1977, what is the difference between the Gross enrolment ratio (%) of Primary schools and Gross enrolment ratio (%) of Tertiary schools?
Your answer should be compact. 77.17. In the year 1977, what is the difference between the Gross enrolment ratio (%) of Secondary schools and Gross enrolment ratio (%) of Tertiary schools?
Offer a very short reply. 18.41. In the year 1978, what is the difference between the Gross enrolment ratio (%) in Pre-primary schools and Gross enrolment ratio (%) in Primary schools?
Provide a succinct answer. -80.31. In the year 1978, what is the difference between the Gross enrolment ratio (%) in Pre-primary schools and Gross enrolment ratio (%) in Secondary schools?
Ensure brevity in your answer.  -18.23. In the year 1978, what is the difference between the Gross enrolment ratio (%) of Pre-primary schools and Gross enrolment ratio (%) of Tertiary schools?
Ensure brevity in your answer.  -0.26. In the year 1978, what is the difference between the Gross enrolment ratio (%) in Primary schools and Gross enrolment ratio (%) in Secondary schools?
Give a very brief answer. 62.09. In the year 1978, what is the difference between the Gross enrolment ratio (%) in Primary schools and Gross enrolment ratio (%) in Tertiary schools?
Give a very brief answer. 80.05. In the year 1978, what is the difference between the Gross enrolment ratio (%) of Secondary schools and Gross enrolment ratio (%) of Tertiary schools?
Make the answer very short. 17.96. In the year 1979, what is the difference between the Gross enrolment ratio (%) of Pre-primary schools and Gross enrolment ratio (%) of Primary schools?
Your response must be concise. -86.62. In the year 1979, what is the difference between the Gross enrolment ratio (%) in Pre-primary schools and Gross enrolment ratio (%) in Secondary schools?
Make the answer very short. -21.17. In the year 1979, what is the difference between the Gross enrolment ratio (%) in Pre-primary schools and Gross enrolment ratio (%) in Tertiary schools?
Your answer should be very brief. -0.55. In the year 1979, what is the difference between the Gross enrolment ratio (%) of Primary schools and Gross enrolment ratio (%) of Secondary schools?
Provide a succinct answer. 65.46. In the year 1979, what is the difference between the Gross enrolment ratio (%) of Primary schools and Gross enrolment ratio (%) of Tertiary schools?
Your answer should be compact. 86.07. In the year 1979, what is the difference between the Gross enrolment ratio (%) of Secondary schools and Gross enrolment ratio (%) of Tertiary schools?
Keep it short and to the point. 20.61. What is the ratio of the Gross enrolment ratio (%) of Pre-primary schools in 1973 to that in 1974?
Offer a very short reply. 1. What is the ratio of the Gross enrolment ratio (%) of Primary schools in 1973 to that in 1974?
Your answer should be very brief. 0.98. What is the ratio of the Gross enrolment ratio (%) of Secondary schools in 1973 to that in 1974?
Keep it short and to the point. 1.21. What is the ratio of the Gross enrolment ratio (%) in Tertiary schools in 1973 to that in 1974?
Your response must be concise. 0.9. What is the ratio of the Gross enrolment ratio (%) in Pre-primary schools in 1973 to that in 1975?
Offer a terse response. 0.84. What is the ratio of the Gross enrolment ratio (%) of Primary schools in 1973 to that in 1975?
Ensure brevity in your answer.  0.98. What is the ratio of the Gross enrolment ratio (%) in Secondary schools in 1973 to that in 1975?
Give a very brief answer. 1.13. What is the ratio of the Gross enrolment ratio (%) in Tertiary schools in 1973 to that in 1975?
Your answer should be very brief. 0.87. What is the ratio of the Gross enrolment ratio (%) in Pre-primary schools in 1973 to that in 1976?
Offer a very short reply. 0.69. What is the ratio of the Gross enrolment ratio (%) of Primary schools in 1973 to that in 1976?
Keep it short and to the point. 0.96. What is the ratio of the Gross enrolment ratio (%) in Secondary schools in 1973 to that in 1976?
Ensure brevity in your answer.  0.79. What is the ratio of the Gross enrolment ratio (%) in Tertiary schools in 1973 to that in 1976?
Your answer should be compact. 0.76. What is the ratio of the Gross enrolment ratio (%) of Pre-primary schools in 1973 to that in 1977?
Keep it short and to the point. 0.57. What is the ratio of the Gross enrolment ratio (%) in Primary schools in 1973 to that in 1977?
Your answer should be compact. 0.97. What is the ratio of the Gross enrolment ratio (%) in Secondary schools in 1973 to that in 1977?
Your answer should be compact. 0.7. What is the ratio of the Gross enrolment ratio (%) in Tertiary schools in 1973 to that in 1977?
Your answer should be very brief. 0.72. What is the ratio of the Gross enrolment ratio (%) of Pre-primary schools in 1973 to that in 1978?
Make the answer very short. 0.5. What is the ratio of the Gross enrolment ratio (%) of Primary schools in 1973 to that in 1978?
Give a very brief answer. 0.94. What is the ratio of the Gross enrolment ratio (%) in Secondary schools in 1973 to that in 1978?
Make the answer very short. 0.71. What is the ratio of the Gross enrolment ratio (%) in Tertiary schools in 1973 to that in 1978?
Your answer should be very brief. 0.72. What is the ratio of the Gross enrolment ratio (%) of Pre-primary schools in 1973 to that in 1979?
Your answer should be very brief. 0.52. What is the ratio of the Gross enrolment ratio (%) of Primary schools in 1973 to that in 1979?
Your answer should be compact. 0.88. What is the ratio of the Gross enrolment ratio (%) in Secondary schools in 1973 to that in 1979?
Keep it short and to the point. 0.64. What is the ratio of the Gross enrolment ratio (%) of Tertiary schools in 1973 to that in 1979?
Your answer should be compact. 0.72. What is the ratio of the Gross enrolment ratio (%) of Pre-primary schools in 1974 to that in 1975?
Offer a terse response. 0.84. What is the ratio of the Gross enrolment ratio (%) of Secondary schools in 1974 to that in 1975?
Make the answer very short. 0.93. What is the ratio of the Gross enrolment ratio (%) in Tertiary schools in 1974 to that in 1975?
Give a very brief answer. 0.97. What is the ratio of the Gross enrolment ratio (%) in Pre-primary schools in 1974 to that in 1976?
Offer a very short reply. 0.69. What is the ratio of the Gross enrolment ratio (%) in Primary schools in 1974 to that in 1976?
Give a very brief answer. 0.98. What is the ratio of the Gross enrolment ratio (%) in Secondary schools in 1974 to that in 1976?
Provide a short and direct response. 0.65. What is the ratio of the Gross enrolment ratio (%) of Tertiary schools in 1974 to that in 1976?
Offer a terse response. 0.84. What is the ratio of the Gross enrolment ratio (%) of Pre-primary schools in 1974 to that in 1977?
Make the answer very short. 0.57. What is the ratio of the Gross enrolment ratio (%) of Primary schools in 1974 to that in 1977?
Your answer should be very brief. 0.99. What is the ratio of the Gross enrolment ratio (%) of Secondary schools in 1974 to that in 1977?
Provide a succinct answer. 0.57. What is the ratio of the Gross enrolment ratio (%) of Tertiary schools in 1974 to that in 1977?
Your answer should be compact. 0.8. What is the ratio of the Gross enrolment ratio (%) of Pre-primary schools in 1974 to that in 1978?
Your response must be concise. 0.5. What is the ratio of the Gross enrolment ratio (%) in Primary schools in 1974 to that in 1978?
Give a very brief answer. 0.96. What is the ratio of the Gross enrolment ratio (%) in Secondary schools in 1974 to that in 1978?
Your answer should be compact. 0.58. What is the ratio of the Gross enrolment ratio (%) of Tertiary schools in 1974 to that in 1978?
Offer a terse response. 0.8. What is the ratio of the Gross enrolment ratio (%) in Pre-primary schools in 1974 to that in 1979?
Ensure brevity in your answer.  0.52. What is the ratio of the Gross enrolment ratio (%) in Primary schools in 1974 to that in 1979?
Provide a succinct answer. 0.9. What is the ratio of the Gross enrolment ratio (%) of Secondary schools in 1974 to that in 1979?
Your response must be concise. 0.53. What is the ratio of the Gross enrolment ratio (%) in Tertiary schools in 1974 to that in 1979?
Provide a short and direct response. 0.8. What is the ratio of the Gross enrolment ratio (%) in Pre-primary schools in 1975 to that in 1976?
Give a very brief answer. 0.82. What is the ratio of the Gross enrolment ratio (%) in Tertiary schools in 1975 to that in 1976?
Provide a short and direct response. 0.87. What is the ratio of the Gross enrolment ratio (%) of Pre-primary schools in 1975 to that in 1977?
Provide a short and direct response. 0.68. What is the ratio of the Gross enrolment ratio (%) of Primary schools in 1975 to that in 1977?
Provide a succinct answer. 1. What is the ratio of the Gross enrolment ratio (%) in Secondary schools in 1975 to that in 1977?
Offer a terse response. 0.62. What is the ratio of the Gross enrolment ratio (%) of Tertiary schools in 1975 to that in 1977?
Keep it short and to the point. 0.83. What is the ratio of the Gross enrolment ratio (%) in Pre-primary schools in 1975 to that in 1978?
Provide a short and direct response. 0.6. What is the ratio of the Gross enrolment ratio (%) in Primary schools in 1975 to that in 1978?
Your response must be concise. 0.96. What is the ratio of the Gross enrolment ratio (%) in Secondary schools in 1975 to that in 1978?
Provide a succinct answer. 0.63. What is the ratio of the Gross enrolment ratio (%) in Tertiary schools in 1975 to that in 1978?
Your response must be concise. 0.83. What is the ratio of the Gross enrolment ratio (%) of Pre-primary schools in 1975 to that in 1979?
Your response must be concise. 0.62. What is the ratio of the Gross enrolment ratio (%) of Primary schools in 1975 to that in 1979?
Your response must be concise. 0.9. What is the ratio of the Gross enrolment ratio (%) in Secondary schools in 1975 to that in 1979?
Offer a very short reply. 0.57. What is the ratio of the Gross enrolment ratio (%) in Tertiary schools in 1975 to that in 1979?
Your answer should be compact. 0.83. What is the ratio of the Gross enrolment ratio (%) in Pre-primary schools in 1976 to that in 1977?
Keep it short and to the point. 0.83. What is the ratio of the Gross enrolment ratio (%) in Primary schools in 1976 to that in 1977?
Your response must be concise. 1.01. What is the ratio of the Gross enrolment ratio (%) of Secondary schools in 1976 to that in 1977?
Give a very brief answer. 0.88. What is the ratio of the Gross enrolment ratio (%) in Tertiary schools in 1976 to that in 1977?
Offer a terse response. 0.95. What is the ratio of the Gross enrolment ratio (%) of Pre-primary schools in 1976 to that in 1978?
Ensure brevity in your answer.  0.73. What is the ratio of the Gross enrolment ratio (%) of Primary schools in 1976 to that in 1978?
Keep it short and to the point. 0.98. What is the ratio of the Gross enrolment ratio (%) of Secondary schools in 1976 to that in 1978?
Your answer should be very brief. 0.9. What is the ratio of the Gross enrolment ratio (%) of Tertiary schools in 1976 to that in 1978?
Keep it short and to the point. 0.95. What is the ratio of the Gross enrolment ratio (%) in Pre-primary schools in 1976 to that in 1979?
Provide a short and direct response. 0.76. What is the ratio of the Gross enrolment ratio (%) in Primary schools in 1976 to that in 1979?
Your answer should be very brief. 0.92. What is the ratio of the Gross enrolment ratio (%) of Secondary schools in 1976 to that in 1979?
Keep it short and to the point. 0.82. What is the ratio of the Gross enrolment ratio (%) in Tertiary schools in 1976 to that in 1979?
Offer a very short reply. 0.95. What is the ratio of the Gross enrolment ratio (%) of Pre-primary schools in 1977 to that in 1978?
Offer a terse response. 0.88. What is the ratio of the Gross enrolment ratio (%) of Primary schools in 1977 to that in 1978?
Your answer should be very brief. 0.97. What is the ratio of the Gross enrolment ratio (%) of Secondary schools in 1977 to that in 1978?
Your answer should be very brief. 1.02. What is the ratio of the Gross enrolment ratio (%) of Tertiary schools in 1977 to that in 1978?
Your response must be concise. 1. What is the ratio of the Gross enrolment ratio (%) in Pre-primary schools in 1977 to that in 1979?
Provide a succinct answer. 0.91. What is the ratio of the Gross enrolment ratio (%) of Primary schools in 1977 to that in 1979?
Your response must be concise. 0.91. What is the ratio of the Gross enrolment ratio (%) of Secondary schools in 1977 to that in 1979?
Your answer should be very brief. 0.92. What is the ratio of the Gross enrolment ratio (%) of Pre-primary schools in 1978 to that in 1979?
Keep it short and to the point. 1.03. What is the ratio of the Gross enrolment ratio (%) of Primary schools in 1978 to that in 1979?
Offer a very short reply. 0.94. What is the ratio of the Gross enrolment ratio (%) of Secondary schools in 1978 to that in 1979?
Offer a very short reply. 0.91. What is the difference between the highest and the second highest Gross enrolment ratio (%) of Pre-primary schools?
Ensure brevity in your answer.  0.27. What is the difference between the highest and the second highest Gross enrolment ratio (%) of Primary schools?
Keep it short and to the point. 6.04. What is the difference between the highest and the second highest Gross enrolment ratio (%) of Secondary schools?
Offer a terse response. 2.23. What is the difference between the highest and the second highest Gross enrolment ratio (%) of Tertiary schools?
Offer a very short reply. 0.02. What is the difference between the highest and the lowest Gross enrolment ratio (%) of Pre-primary schools?
Keep it short and to the point. 4.25. What is the difference between the highest and the lowest Gross enrolment ratio (%) in Primary schools?
Keep it short and to the point. 11.21. What is the difference between the highest and the lowest Gross enrolment ratio (%) of Secondary schools?
Keep it short and to the point. 13.8. What is the difference between the highest and the lowest Gross enrolment ratio (%) of Tertiary schools?
Your answer should be compact. 2.48. 